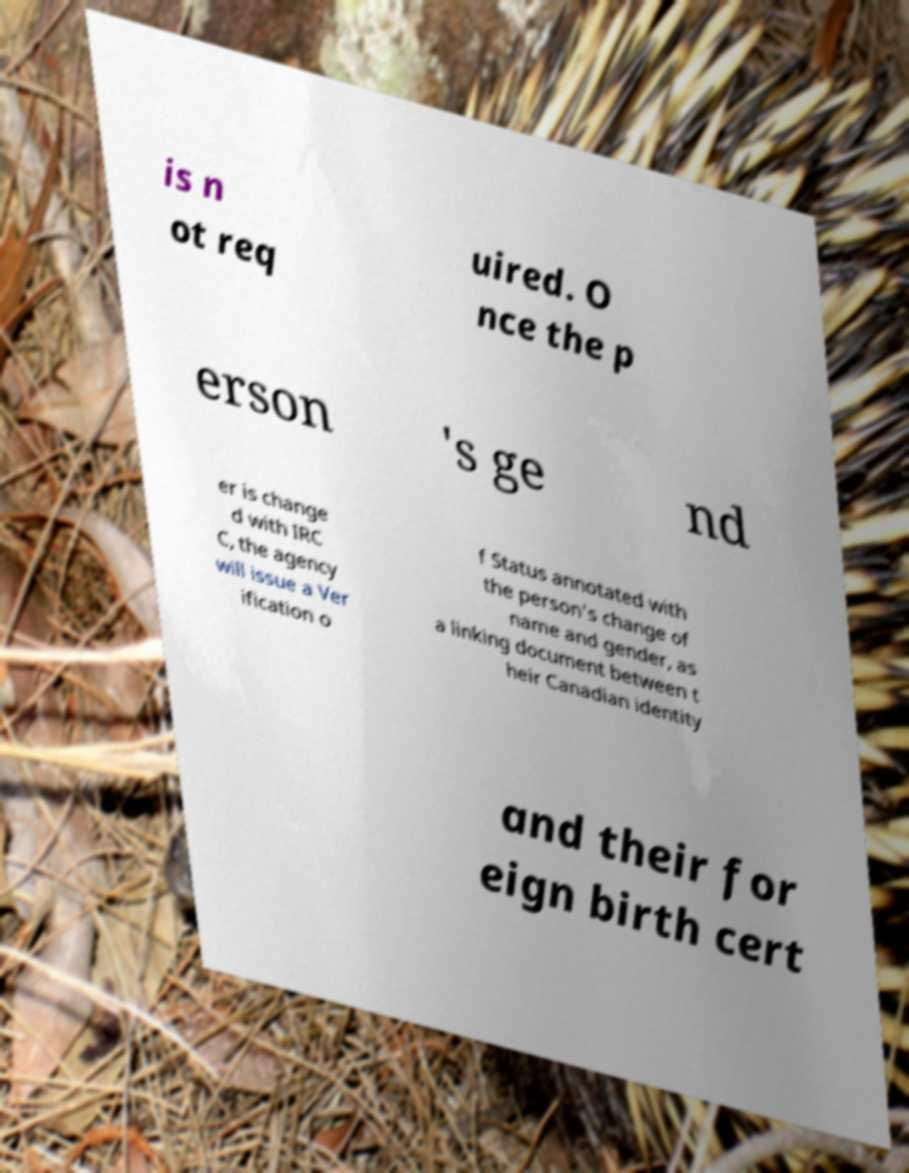What messages or text are displayed in this image? I need them in a readable, typed format. is n ot req uired. O nce the p erson 's ge nd er is change d with IRC C, the agency will issue a Ver ification o f Status annotated with the person's change of name and gender, as a linking document between t heir Canadian identity and their for eign birth cert 